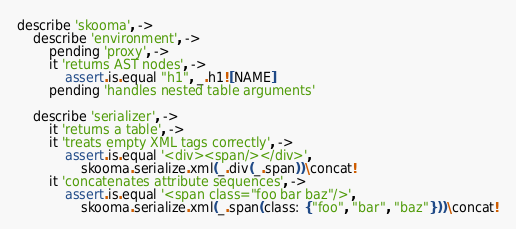Convert code to text. <code><loc_0><loc_0><loc_500><loc_500><_MoonScript_>describe 'skooma', ->
	describe 'environment', ->
		pending 'proxy', ->
		it 'returns AST nodes', ->
			assert.is.equal "h1", _.h1![NAME]
		pending 'handles nested table arguments'
	
	describe 'serializer', ->
		it 'returns a table', ->
		it 'treats empty XML tags correctly', ->
			assert.is.equal '<div><span/></div>',
				skooma.serialize.xml(_.div(_.span))\concat!
		it 'concatenates attribute sequences', ->
			assert.is.equal '<span class="foo bar baz"/>',
				skooma.serialize.xml(_.span(class: {"foo", "bar", "baz"}))\concat!
</code> 